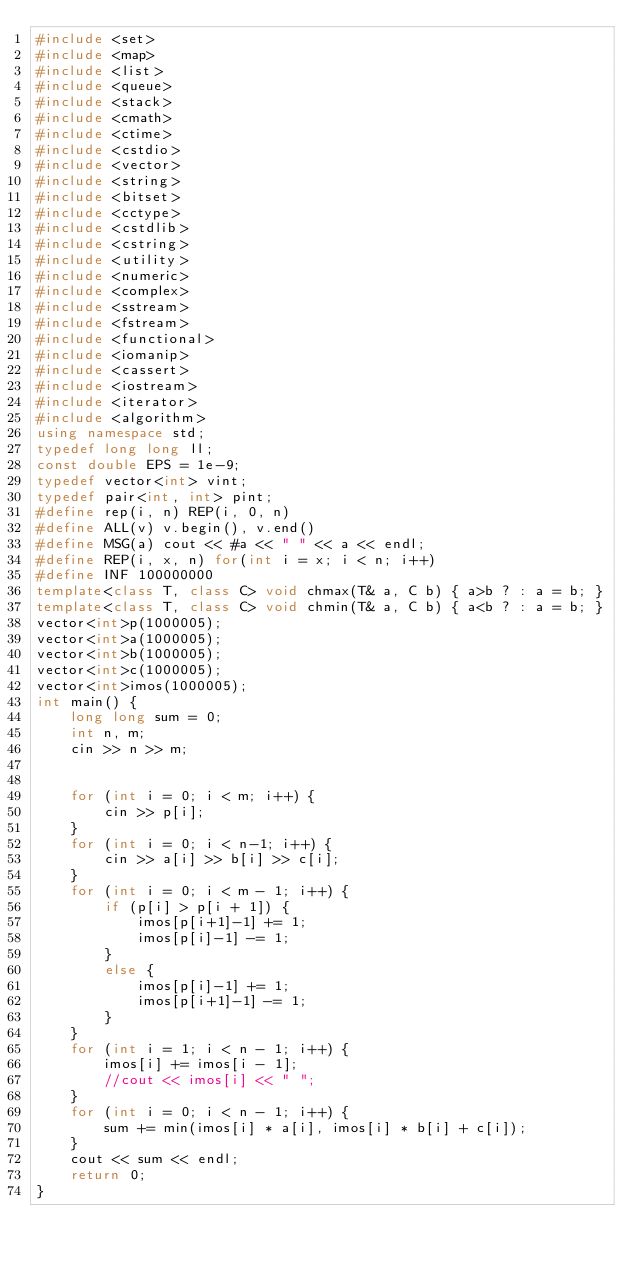<code> <loc_0><loc_0><loc_500><loc_500><_C++_>#include <set>
#include <map>
#include <list>
#include <queue>
#include <stack>
#include <cmath>
#include <ctime>
#include <cstdio>
#include <vector>
#include <string>
#include <bitset>
#include <cctype>
#include <cstdlib>
#include <cstring>
#include <utility>
#include <numeric>
#include <complex>
#include <sstream>
#include <fstream>
#include <functional>
#include <iomanip>
#include <cassert>
#include <iostream>
#include <iterator>
#include <algorithm>
using namespace std;
typedef long long ll;
const double EPS = 1e-9;
typedef vector<int> vint;
typedef pair<int, int> pint;
#define rep(i, n) REP(i, 0, n)
#define ALL(v) v.begin(), v.end()
#define MSG(a) cout << #a << " " << a << endl;
#define REP(i, x, n) for(int i = x; i < n; i++)
#define INF 100000000
template<class T, class C> void chmax(T& a, C b) { a>b ? : a = b; }
template<class T, class C> void chmin(T& a, C b) { a<b ? : a = b; }
vector<int>p(1000005);
vector<int>a(1000005);
vector<int>b(1000005);
vector<int>c(1000005);
vector<int>imos(1000005);
int main() {
	long long sum = 0;
	int n, m;
	cin >> n >> m;
	
	
	for (int i = 0; i < m; i++) {
		cin >> p[i];
	}
	for (int i = 0; i < n-1; i++) {
		cin >> a[i] >> b[i] >> c[i];
	}
	for (int i = 0; i < m - 1; i++) {
		if (p[i] > p[i + 1]) {
			imos[p[i+1]-1] += 1;
			imos[p[i]-1] -= 1;
		}
		else {
			imos[p[i]-1] += 1;
			imos[p[i+1]-1] -= 1;
		}
	}
	for (int i = 1; i < n - 1; i++) {
		imos[i] += imos[i - 1];
		//cout << imos[i] << " ";
	}
	for (int i = 0; i < n - 1; i++) {
		sum += min(imos[i] * a[i], imos[i] * b[i] + c[i]);
	}
	cout << sum << endl;
	return 0;
}</code> 